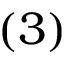Convert formula to latex. <formula><loc_0><loc_0><loc_500><loc_500>{ ( 3 ) }</formula> 